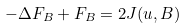<formula> <loc_0><loc_0><loc_500><loc_500>- \Delta F _ { B } + F _ { B } = 2 J ( u , B )</formula> 